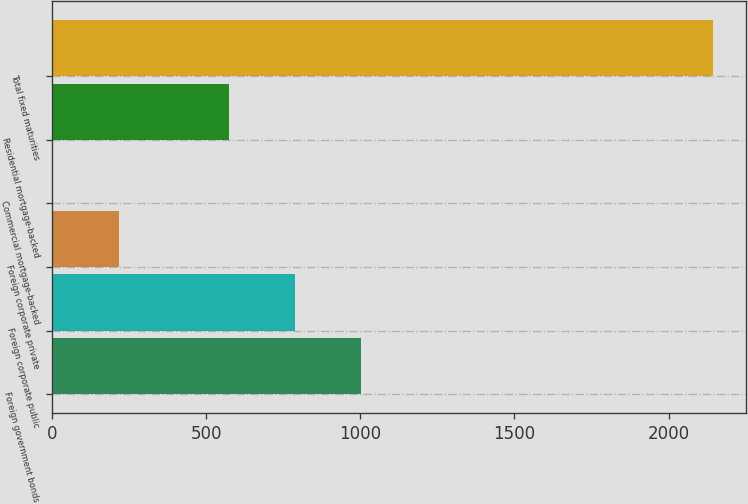Convert chart. <chart><loc_0><loc_0><loc_500><loc_500><bar_chart><fcel>Foreign government bonds<fcel>Foreign corporate public<fcel>Foreign corporate private<fcel>Commercial mortgage-backed<fcel>Residential mortgage-backed<fcel>Total fixed maturities<nl><fcel>1000.94<fcel>786.97<fcel>218.32<fcel>4.35<fcel>573<fcel>2144<nl></chart> 